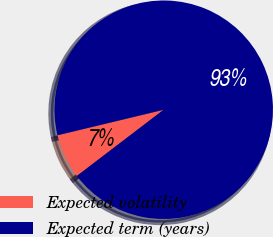Convert chart to OTSL. <chart><loc_0><loc_0><loc_500><loc_500><pie_chart><fcel>Expected volatility<fcel>Expected term (years)<nl><fcel>6.62%<fcel>93.38%<nl></chart> 